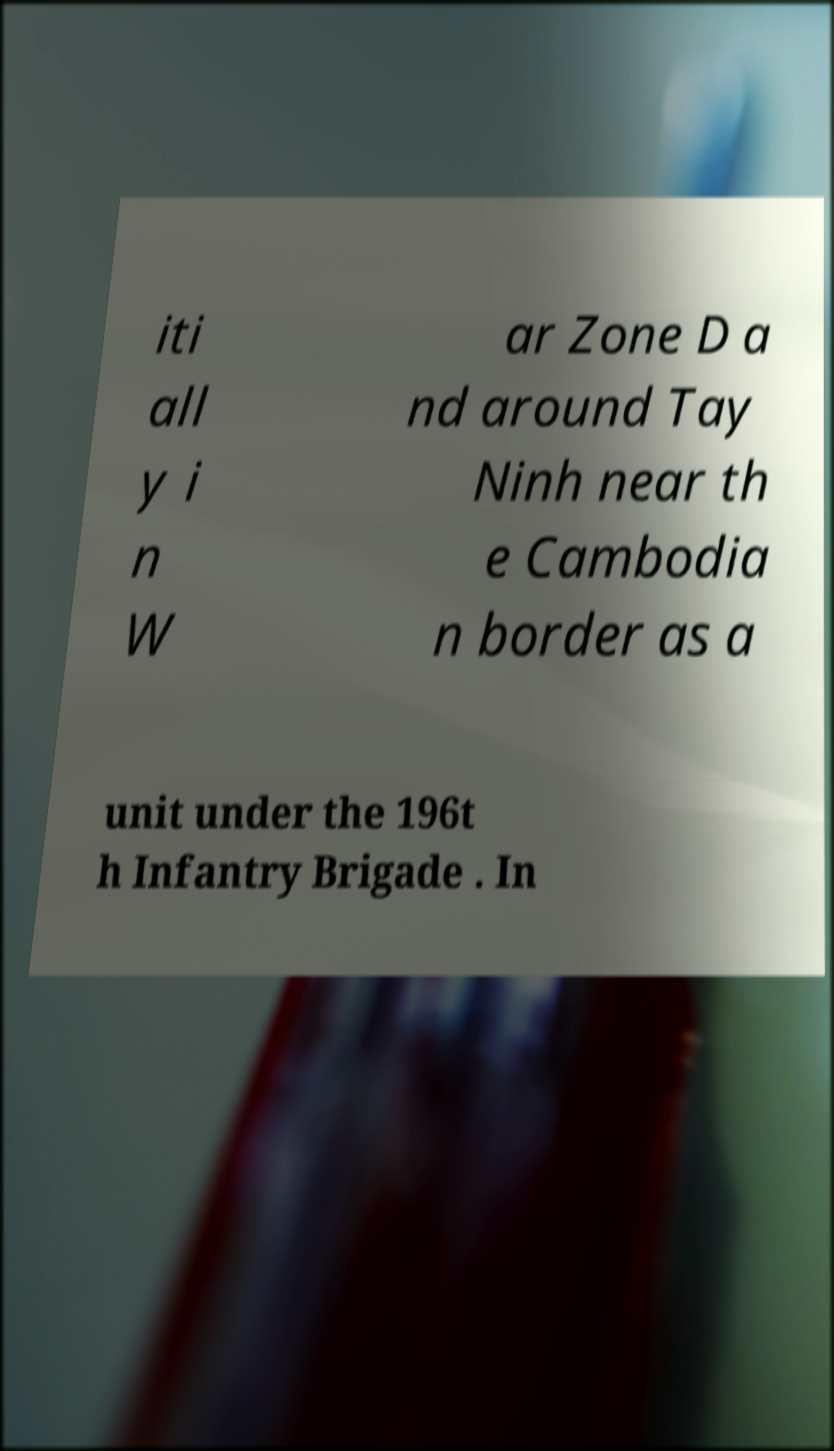I need the written content from this picture converted into text. Can you do that? iti all y i n W ar Zone D a nd around Tay Ninh near th e Cambodia n border as a unit under the 196t h Infantry Brigade . In 